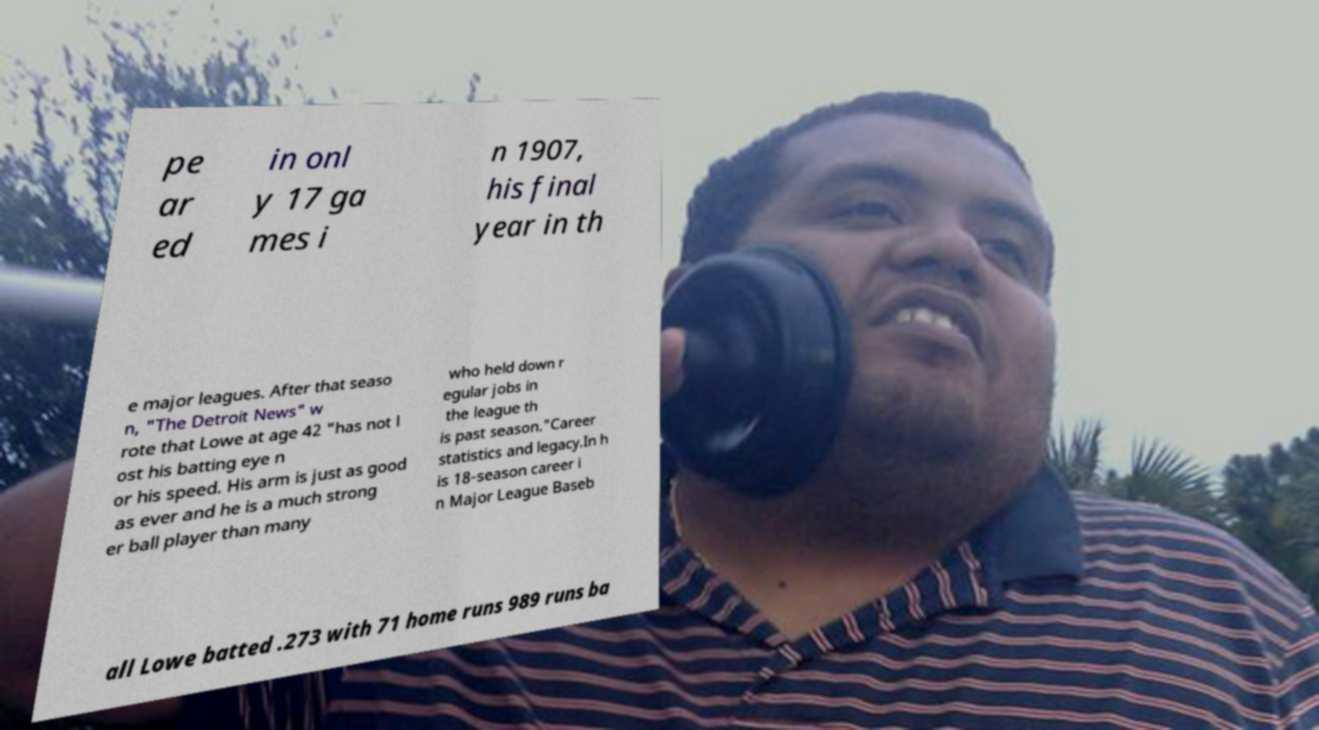Please identify and transcribe the text found in this image. pe ar ed in onl y 17 ga mes i n 1907, his final year in th e major leagues. After that seaso n, "The Detroit News" w rote that Lowe at age 42 "has not l ost his batting eye n or his speed. His arm is just as good as ever and he is a much strong er ball player than many who held down r egular jobs in the league th is past season."Career statistics and legacy.In h is 18-season career i n Major League Baseb all Lowe batted .273 with 71 home runs 989 runs ba 